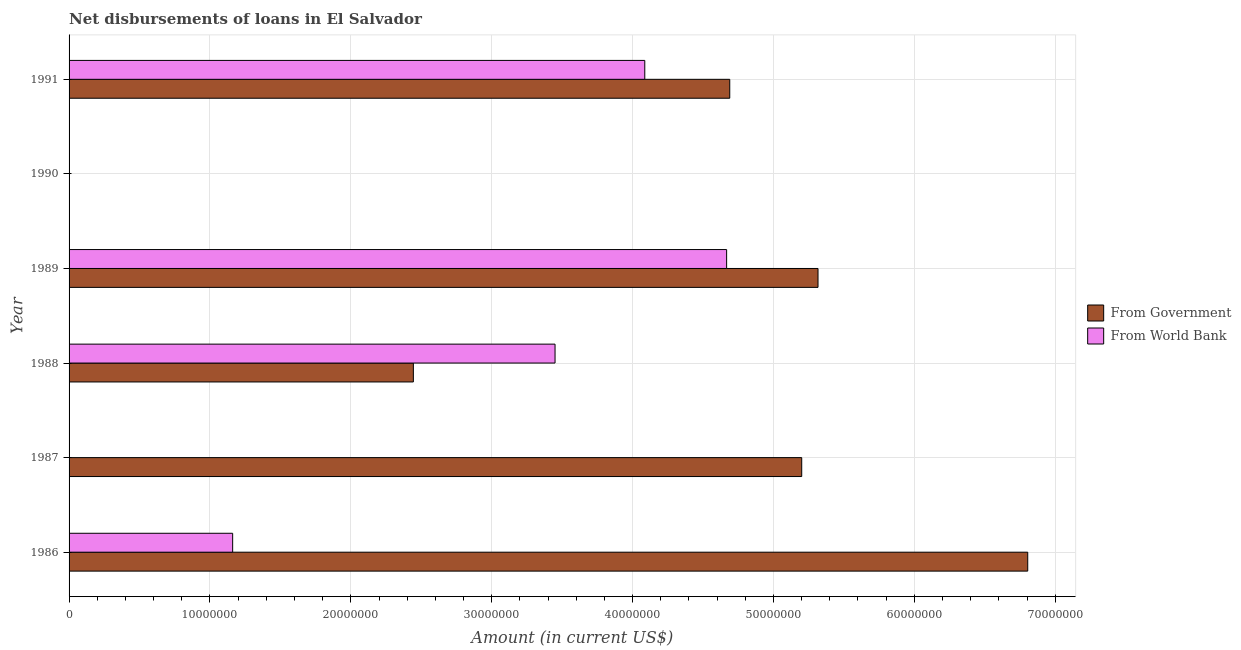How many different coloured bars are there?
Keep it short and to the point. 2. Are the number of bars on each tick of the Y-axis equal?
Keep it short and to the point. No. How many bars are there on the 6th tick from the top?
Ensure brevity in your answer.  2. How many bars are there on the 6th tick from the bottom?
Your answer should be very brief. 2. What is the net disbursements of loan from government in 1991?
Offer a terse response. 4.69e+07. Across all years, what is the maximum net disbursements of loan from government?
Your response must be concise. 6.80e+07. In which year was the net disbursements of loan from government maximum?
Provide a short and direct response. 1986. What is the total net disbursements of loan from government in the graph?
Provide a succinct answer. 2.45e+08. What is the difference between the net disbursements of loan from world bank in 1986 and that in 1989?
Your response must be concise. -3.51e+07. What is the difference between the net disbursements of loan from government in 1986 and the net disbursements of loan from world bank in 1987?
Offer a terse response. 6.80e+07. What is the average net disbursements of loan from government per year?
Provide a succinct answer. 4.08e+07. In the year 1991, what is the difference between the net disbursements of loan from world bank and net disbursements of loan from government?
Offer a very short reply. -6.03e+06. What is the ratio of the net disbursements of loan from world bank in 1986 to that in 1989?
Ensure brevity in your answer.  0.25. Is the net disbursements of loan from world bank in 1986 less than that in 1991?
Your answer should be compact. Yes. Is the difference between the net disbursements of loan from world bank in 1989 and 1991 greater than the difference between the net disbursements of loan from government in 1989 and 1991?
Make the answer very short. No. What is the difference between the highest and the second highest net disbursements of loan from world bank?
Give a very brief answer. 5.81e+06. What is the difference between the highest and the lowest net disbursements of loan from government?
Your answer should be compact. 6.80e+07. Is the sum of the net disbursements of loan from world bank in 1988 and 1991 greater than the maximum net disbursements of loan from government across all years?
Ensure brevity in your answer.  Yes. Are all the bars in the graph horizontal?
Offer a terse response. Yes. How many years are there in the graph?
Ensure brevity in your answer.  6. What is the difference between two consecutive major ticks on the X-axis?
Your answer should be very brief. 1.00e+07. Are the values on the major ticks of X-axis written in scientific E-notation?
Keep it short and to the point. No. Does the graph contain any zero values?
Your answer should be compact. Yes. How are the legend labels stacked?
Give a very brief answer. Vertical. What is the title of the graph?
Offer a very short reply. Net disbursements of loans in El Salvador. Does "Merchandise exports" appear as one of the legend labels in the graph?
Your answer should be very brief. No. What is the Amount (in current US$) in From Government in 1986?
Provide a short and direct response. 6.80e+07. What is the Amount (in current US$) in From World Bank in 1986?
Give a very brief answer. 1.16e+07. What is the Amount (in current US$) of From Government in 1987?
Give a very brief answer. 5.20e+07. What is the Amount (in current US$) of From World Bank in 1987?
Your answer should be compact. 0. What is the Amount (in current US$) of From Government in 1988?
Ensure brevity in your answer.  2.44e+07. What is the Amount (in current US$) in From World Bank in 1988?
Provide a short and direct response. 3.45e+07. What is the Amount (in current US$) of From Government in 1989?
Offer a very short reply. 5.32e+07. What is the Amount (in current US$) of From World Bank in 1989?
Give a very brief answer. 4.67e+07. What is the Amount (in current US$) of From World Bank in 1990?
Keep it short and to the point. 0. What is the Amount (in current US$) in From Government in 1991?
Your response must be concise. 4.69e+07. What is the Amount (in current US$) of From World Bank in 1991?
Keep it short and to the point. 4.09e+07. Across all years, what is the maximum Amount (in current US$) of From Government?
Give a very brief answer. 6.80e+07. Across all years, what is the maximum Amount (in current US$) of From World Bank?
Offer a terse response. 4.67e+07. Across all years, what is the minimum Amount (in current US$) in From World Bank?
Offer a very short reply. 0. What is the total Amount (in current US$) in From Government in the graph?
Keep it short and to the point. 2.45e+08. What is the total Amount (in current US$) in From World Bank in the graph?
Provide a short and direct response. 1.34e+08. What is the difference between the Amount (in current US$) in From Government in 1986 and that in 1987?
Provide a short and direct response. 1.60e+07. What is the difference between the Amount (in current US$) of From Government in 1986 and that in 1988?
Provide a succinct answer. 4.36e+07. What is the difference between the Amount (in current US$) in From World Bank in 1986 and that in 1988?
Your answer should be compact. -2.29e+07. What is the difference between the Amount (in current US$) in From Government in 1986 and that in 1989?
Ensure brevity in your answer.  1.49e+07. What is the difference between the Amount (in current US$) in From World Bank in 1986 and that in 1989?
Offer a very short reply. -3.51e+07. What is the difference between the Amount (in current US$) of From Government in 1986 and that in 1991?
Ensure brevity in your answer.  2.12e+07. What is the difference between the Amount (in current US$) in From World Bank in 1986 and that in 1991?
Your answer should be compact. -2.93e+07. What is the difference between the Amount (in current US$) of From Government in 1987 and that in 1988?
Provide a short and direct response. 2.76e+07. What is the difference between the Amount (in current US$) in From Government in 1987 and that in 1989?
Provide a short and direct response. -1.16e+06. What is the difference between the Amount (in current US$) of From Government in 1987 and that in 1991?
Offer a very short reply. 5.11e+06. What is the difference between the Amount (in current US$) of From Government in 1988 and that in 1989?
Ensure brevity in your answer.  -2.87e+07. What is the difference between the Amount (in current US$) of From World Bank in 1988 and that in 1989?
Keep it short and to the point. -1.22e+07. What is the difference between the Amount (in current US$) of From Government in 1988 and that in 1991?
Give a very brief answer. -2.25e+07. What is the difference between the Amount (in current US$) in From World Bank in 1988 and that in 1991?
Provide a succinct answer. -6.37e+06. What is the difference between the Amount (in current US$) in From Government in 1989 and that in 1991?
Ensure brevity in your answer.  6.27e+06. What is the difference between the Amount (in current US$) in From World Bank in 1989 and that in 1991?
Offer a terse response. 5.81e+06. What is the difference between the Amount (in current US$) of From Government in 1986 and the Amount (in current US$) of From World Bank in 1988?
Make the answer very short. 3.36e+07. What is the difference between the Amount (in current US$) of From Government in 1986 and the Amount (in current US$) of From World Bank in 1989?
Offer a very short reply. 2.14e+07. What is the difference between the Amount (in current US$) in From Government in 1986 and the Amount (in current US$) in From World Bank in 1991?
Ensure brevity in your answer.  2.72e+07. What is the difference between the Amount (in current US$) of From Government in 1987 and the Amount (in current US$) of From World Bank in 1988?
Give a very brief answer. 1.75e+07. What is the difference between the Amount (in current US$) of From Government in 1987 and the Amount (in current US$) of From World Bank in 1989?
Offer a very short reply. 5.33e+06. What is the difference between the Amount (in current US$) in From Government in 1987 and the Amount (in current US$) in From World Bank in 1991?
Make the answer very short. 1.11e+07. What is the difference between the Amount (in current US$) in From Government in 1988 and the Amount (in current US$) in From World Bank in 1989?
Make the answer very short. -2.22e+07. What is the difference between the Amount (in current US$) of From Government in 1988 and the Amount (in current US$) of From World Bank in 1991?
Provide a succinct answer. -1.64e+07. What is the difference between the Amount (in current US$) in From Government in 1989 and the Amount (in current US$) in From World Bank in 1991?
Ensure brevity in your answer.  1.23e+07. What is the average Amount (in current US$) in From Government per year?
Your answer should be compact. 4.08e+07. What is the average Amount (in current US$) in From World Bank per year?
Offer a terse response. 2.23e+07. In the year 1986, what is the difference between the Amount (in current US$) in From Government and Amount (in current US$) in From World Bank?
Your answer should be compact. 5.64e+07. In the year 1988, what is the difference between the Amount (in current US$) in From Government and Amount (in current US$) in From World Bank?
Your answer should be compact. -1.01e+07. In the year 1989, what is the difference between the Amount (in current US$) in From Government and Amount (in current US$) in From World Bank?
Offer a very short reply. 6.49e+06. In the year 1991, what is the difference between the Amount (in current US$) of From Government and Amount (in current US$) of From World Bank?
Make the answer very short. 6.03e+06. What is the ratio of the Amount (in current US$) in From Government in 1986 to that in 1987?
Keep it short and to the point. 1.31. What is the ratio of the Amount (in current US$) of From Government in 1986 to that in 1988?
Make the answer very short. 2.78. What is the ratio of the Amount (in current US$) in From World Bank in 1986 to that in 1988?
Offer a terse response. 0.34. What is the ratio of the Amount (in current US$) in From Government in 1986 to that in 1989?
Make the answer very short. 1.28. What is the ratio of the Amount (in current US$) of From World Bank in 1986 to that in 1989?
Provide a short and direct response. 0.25. What is the ratio of the Amount (in current US$) of From Government in 1986 to that in 1991?
Keep it short and to the point. 1.45. What is the ratio of the Amount (in current US$) in From World Bank in 1986 to that in 1991?
Provide a succinct answer. 0.28. What is the ratio of the Amount (in current US$) of From Government in 1987 to that in 1988?
Give a very brief answer. 2.13. What is the ratio of the Amount (in current US$) in From Government in 1987 to that in 1989?
Offer a terse response. 0.98. What is the ratio of the Amount (in current US$) of From Government in 1987 to that in 1991?
Give a very brief answer. 1.11. What is the ratio of the Amount (in current US$) of From Government in 1988 to that in 1989?
Provide a succinct answer. 0.46. What is the ratio of the Amount (in current US$) in From World Bank in 1988 to that in 1989?
Your answer should be very brief. 0.74. What is the ratio of the Amount (in current US$) in From Government in 1988 to that in 1991?
Offer a very short reply. 0.52. What is the ratio of the Amount (in current US$) in From World Bank in 1988 to that in 1991?
Give a very brief answer. 0.84. What is the ratio of the Amount (in current US$) in From Government in 1989 to that in 1991?
Keep it short and to the point. 1.13. What is the ratio of the Amount (in current US$) in From World Bank in 1989 to that in 1991?
Ensure brevity in your answer.  1.14. What is the difference between the highest and the second highest Amount (in current US$) in From Government?
Provide a succinct answer. 1.49e+07. What is the difference between the highest and the second highest Amount (in current US$) in From World Bank?
Keep it short and to the point. 5.81e+06. What is the difference between the highest and the lowest Amount (in current US$) in From Government?
Provide a short and direct response. 6.80e+07. What is the difference between the highest and the lowest Amount (in current US$) in From World Bank?
Your answer should be compact. 4.67e+07. 